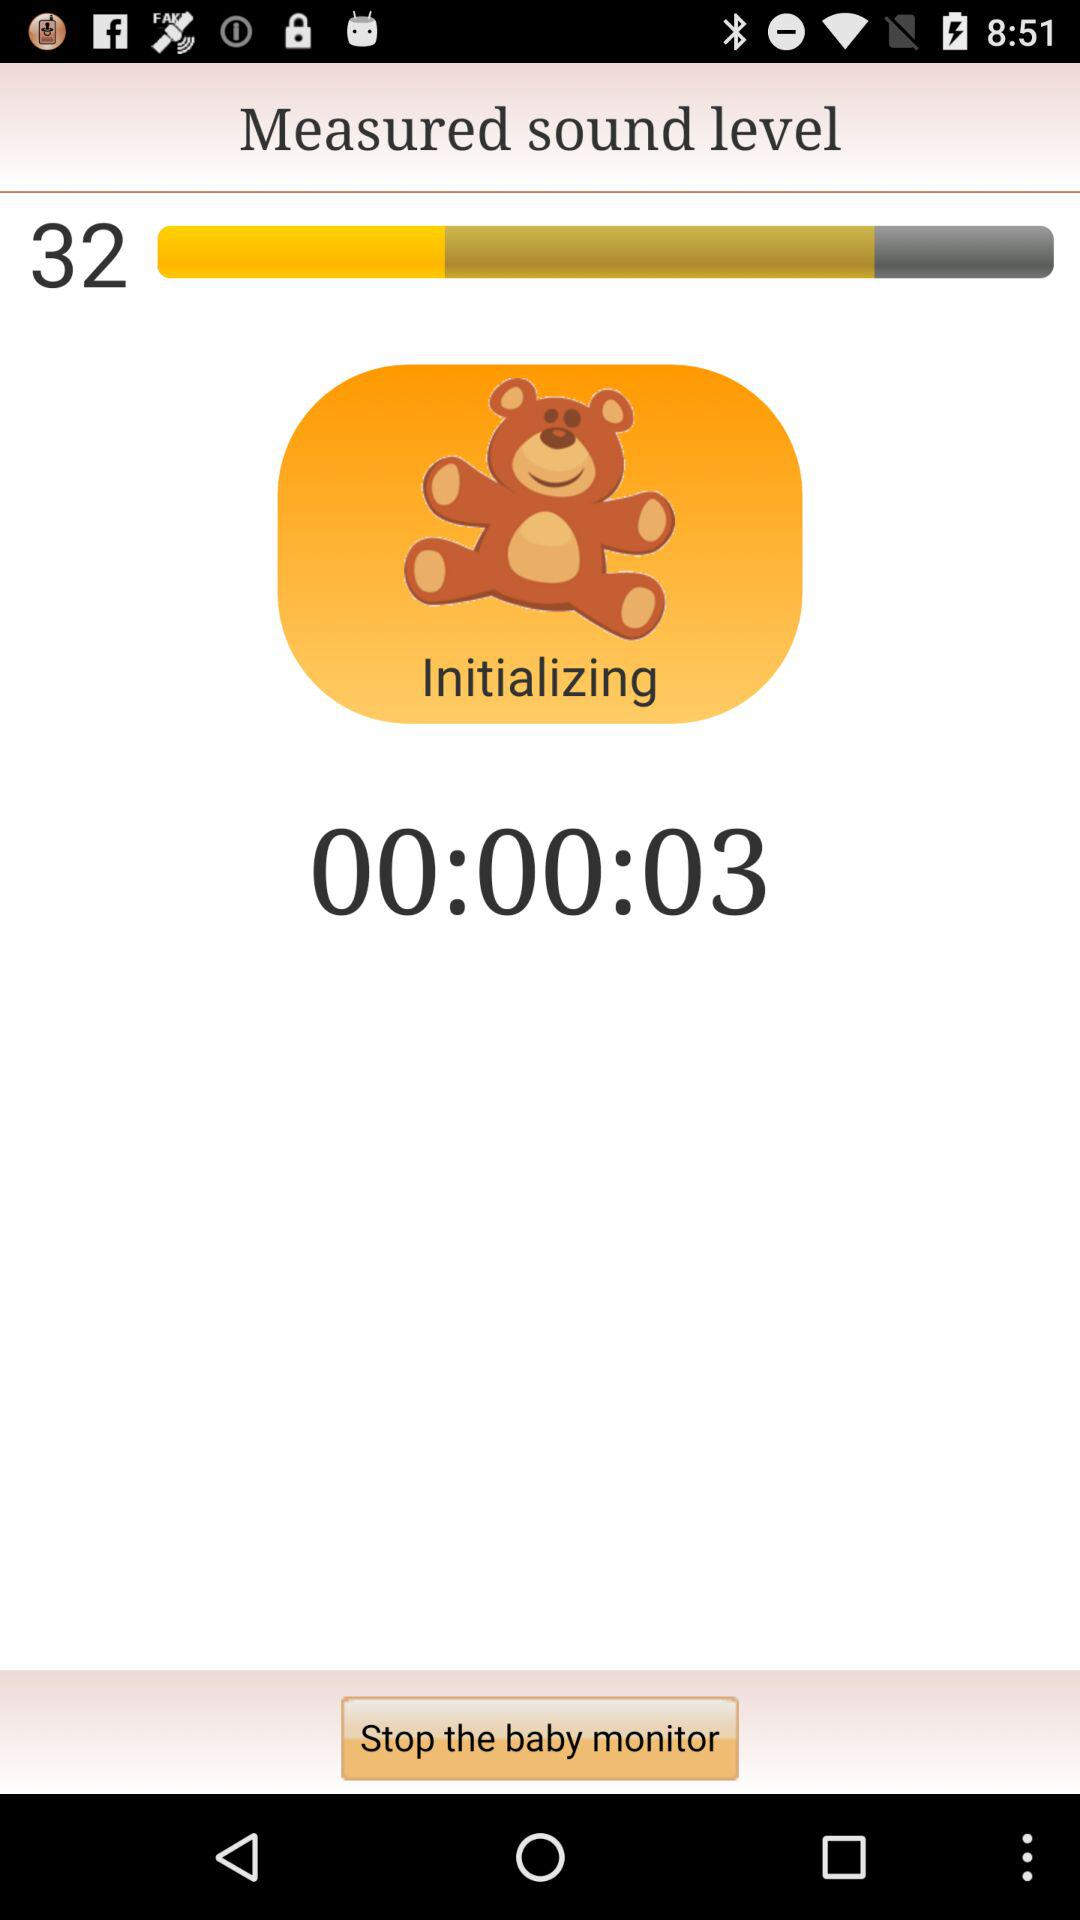How long has the baby been crying for?
Answer the question using a single word or phrase. 00:00:03 